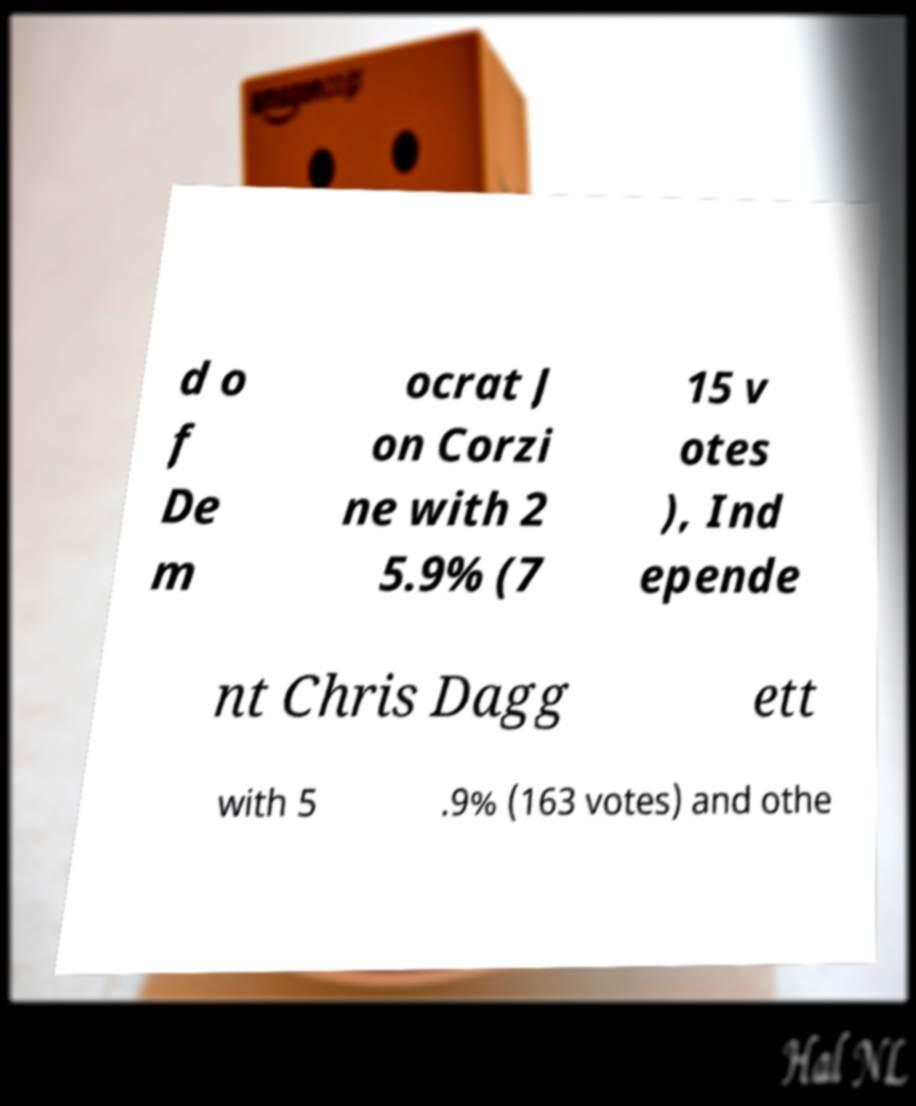I need the written content from this picture converted into text. Can you do that? d o f De m ocrat J on Corzi ne with 2 5.9% (7 15 v otes ), Ind epende nt Chris Dagg ett with 5 .9% (163 votes) and othe 